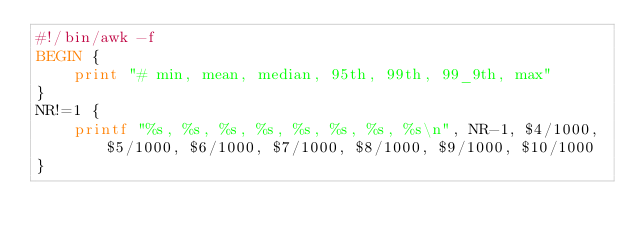<code> <loc_0><loc_0><loc_500><loc_500><_Awk_>#!/bin/awk -f
BEGIN {
    print "# min, mean, median, 95th, 99th, 99_9th, max"
}
NR!=1 {
    printf "%s, %s, %s, %s, %s, %s, %s, %s\n", NR-1, $4/1000, $5/1000, $6/1000, $7/1000, $8/1000, $9/1000, $10/1000
}
</code> 